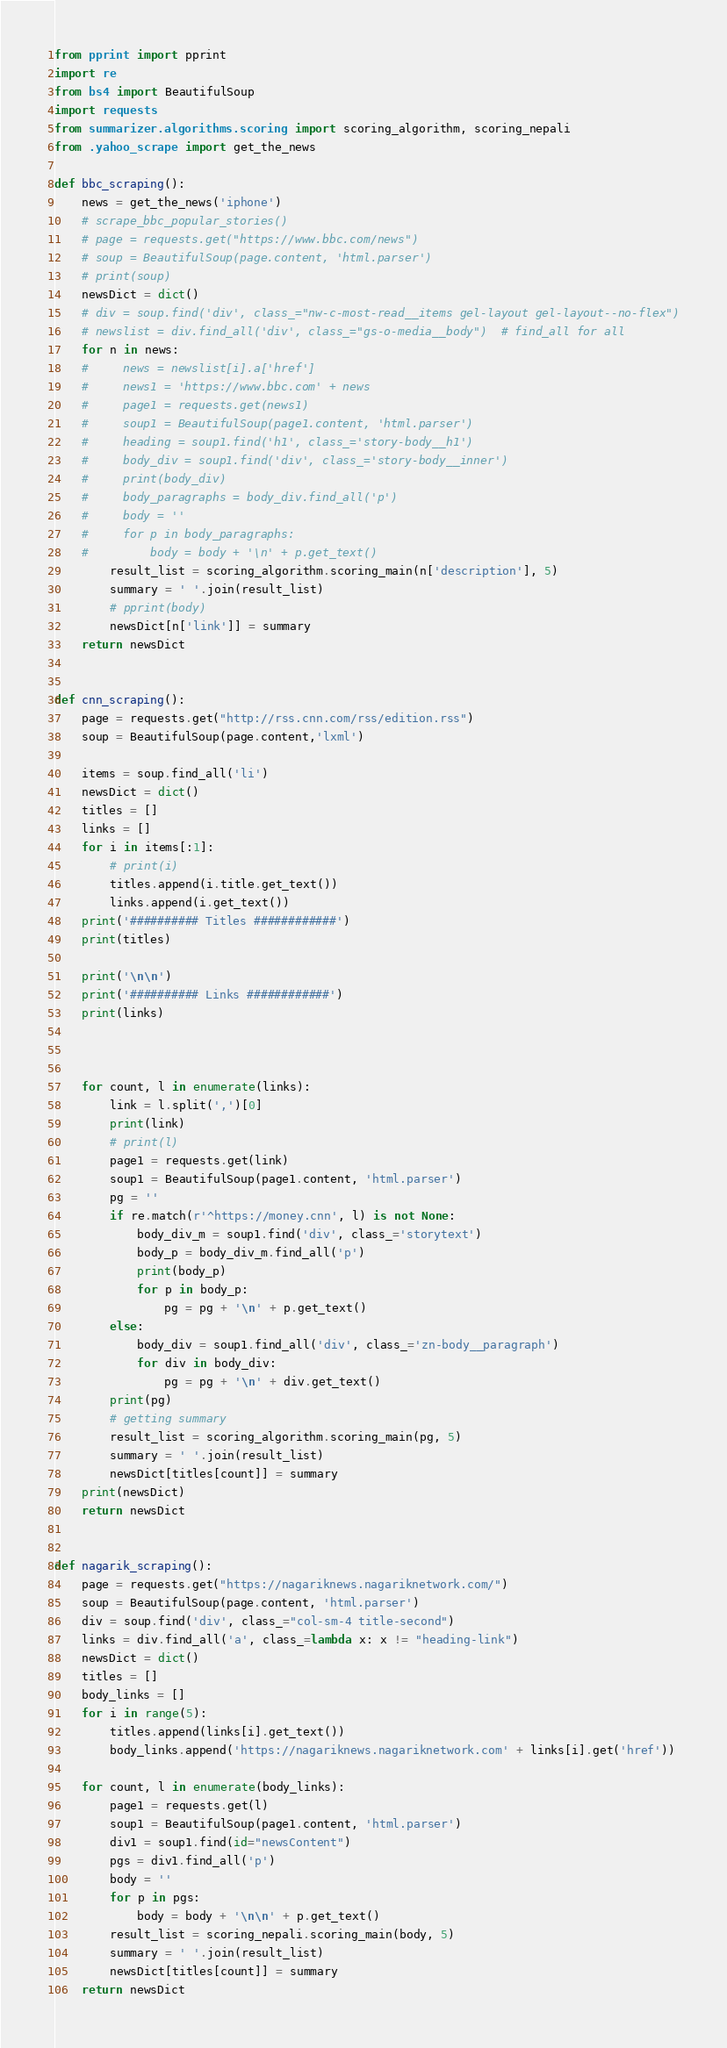Convert code to text. <code><loc_0><loc_0><loc_500><loc_500><_Python_>from pprint import pprint
import re
from bs4 import BeautifulSoup
import requests
from summarizer.algorithms.scoring import scoring_algorithm, scoring_nepali
from .yahoo_scrape import get_the_news

def bbc_scraping():
    news = get_the_news('iphone')
    # scrape_bbc_popular_stories()
    # page = requests.get("https://www.bbc.com/news")
    # soup = BeautifulSoup(page.content, 'html.parser')
    # print(soup)
    newsDict = dict()
    # div = soup.find('div', class_="nw-c-most-read__items gel-layout gel-layout--no-flex")
    # newslist = div.find_all('div', class_="gs-o-media__body")  # find_all for all
    for n in news:
    #     news = newslist[i].a['href']
    #     news1 = 'https://www.bbc.com' + news
    #     page1 = requests.get(news1)
    #     soup1 = BeautifulSoup(page1.content, 'html.parser')
    #     heading = soup1.find('h1', class_='story-body__h1')
    #     body_div = soup1.find('div', class_='story-body__inner')
    #     print(body_div)
    #     body_paragraphs = body_div.find_all('p')
    #     body = ''
    #     for p in body_paragraphs:
    #         body = body + '\n' + p.get_text()
        result_list = scoring_algorithm.scoring_main(n['description'], 5)
        summary = ' '.join(result_list)
        # pprint(body)
        newsDict[n['link']] = summary
    return newsDict


def cnn_scraping():
    page = requests.get("http://rss.cnn.com/rss/edition.rss")
    soup = BeautifulSoup(page.content,'lxml')
    
    items = soup.find_all('li')
    newsDict = dict()
    titles = []
    links = []
    for i in items[:1]:
        # print(i)
        titles.append(i.title.get_text())
        links.append(i.get_text())
    print('########## Titles ############')
    print(titles)

    print('\n\n')
    print('########## Links ############')
    print(links)


    
    for count, l in enumerate(links):
        link = l.split(',')[0]
        print(link)
        # print(l)
        page1 = requests.get(link)
        soup1 = BeautifulSoup(page1.content, 'html.parser')
        pg = ''
        if re.match(r'^https://money.cnn', l) is not None:
            body_div_m = soup1.find('div', class_='storytext')
            body_p = body_div_m.find_all('p')
            print(body_p)
            for p in body_p:
                pg = pg + '\n' + p.get_text()
        else:
            body_div = soup1.find_all('div', class_='zn-body__paragraph')
            for div in body_div:
                pg = pg + '\n' + div.get_text()
        print(pg)
        # getting summary 
        result_list = scoring_algorithm.scoring_main(pg, 5)
        summary = ' '.join(result_list)
        newsDict[titles[count]] = summary
    print(newsDict)
    return newsDict


def nagarik_scraping():
    page = requests.get("https://nagariknews.nagariknetwork.com/")
    soup = BeautifulSoup(page.content, 'html.parser')
    div = soup.find('div', class_="col-sm-4 title-second")
    links = div.find_all('a', class_=lambda x: x != "heading-link")
    newsDict = dict()
    titles = []
    body_links = []
    for i in range(5):
        titles.append(links[i].get_text())
        body_links.append('https://nagariknews.nagariknetwork.com' + links[i].get('href'))

    for count, l in enumerate(body_links):
        page1 = requests.get(l)
        soup1 = BeautifulSoup(page1.content, 'html.parser')
        div1 = soup1.find(id="newsContent")
        pgs = div1.find_all('p')
        body = ''
        for p in pgs:
            body = body + '\n\n' + p.get_text()
        result_list = scoring_nepali.scoring_main(body, 5)
        summary = ' '.join(result_list)
        newsDict[titles[count]] = summary
    return newsDict
</code> 